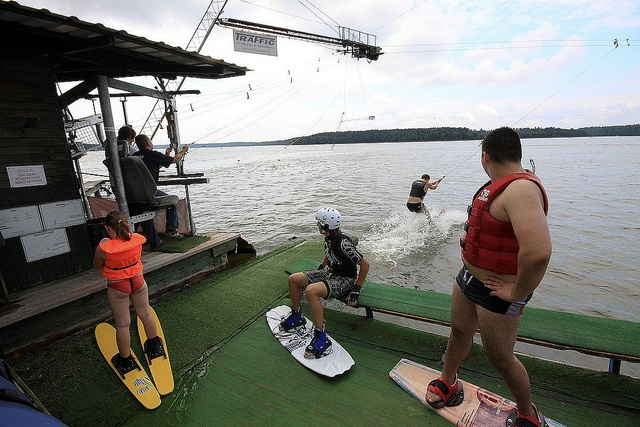Describe the objects in this image and their specific colors. I can see boat in gray, black, and darkgreen tones, people in black, maroon, and gray tones, bench in black and darkgreen tones, people in black, gray, maroon, and darkgray tones, and people in black, maroon, and brown tones in this image. 